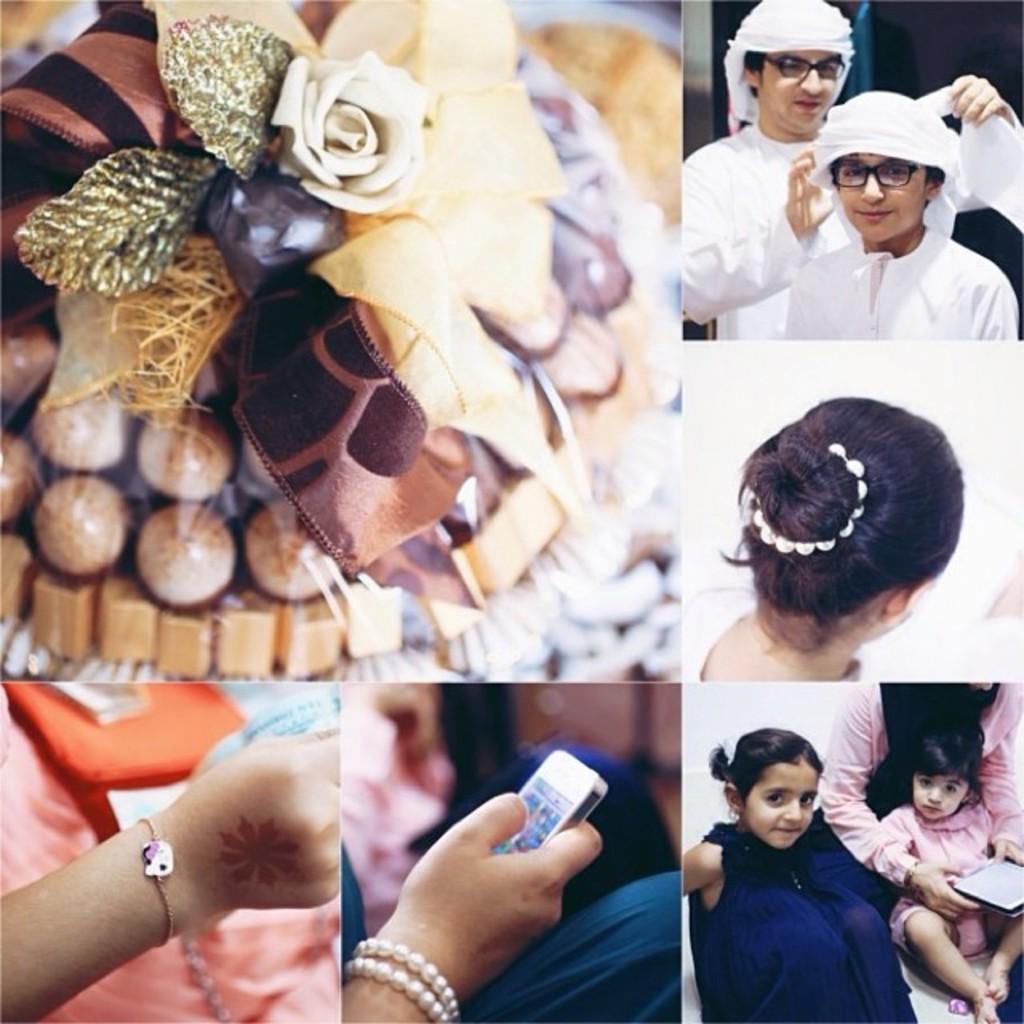Describe this image in one or two sentences. In this image there is a collage, there is an object on the surface, there are two people towards the right of the image, there is a mobile phone, there is a hand truncated towards the bottom of the image, there are persons sitting, there is an object truncated towards the right of the image. 